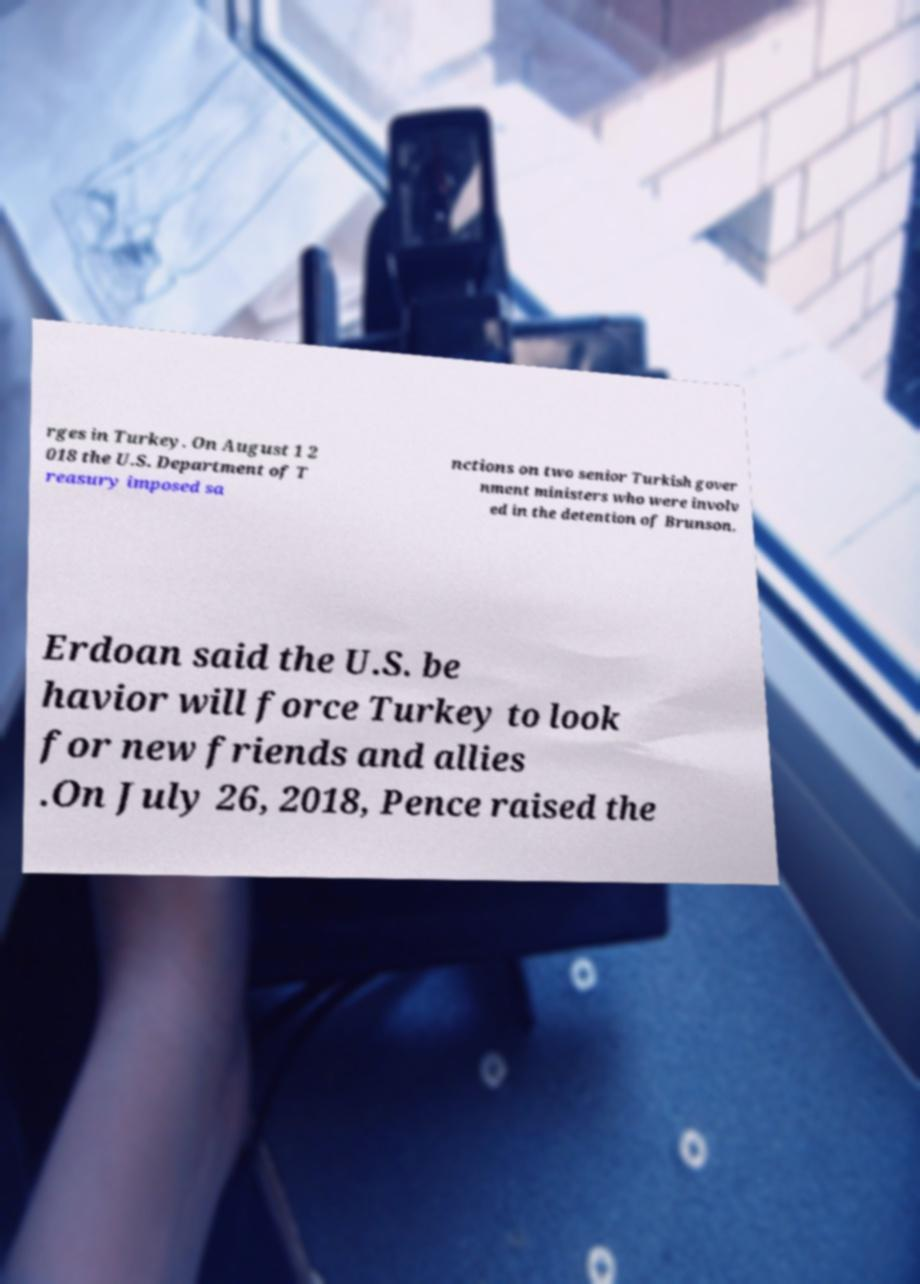Can you read and provide the text displayed in the image?This photo seems to have some interesting text. Can you extract and type it out for me? rges in Turkey. On August 1 2 018 the U.S. Department of T reasury imposed sa nctions on two senior Turkish gover nment ministers who were involv ed in the detention of Brunson. Erdoan said the U.S. be havior will force Turkey to look for new friends and allies .On July 26, 2018, Pence raised the 